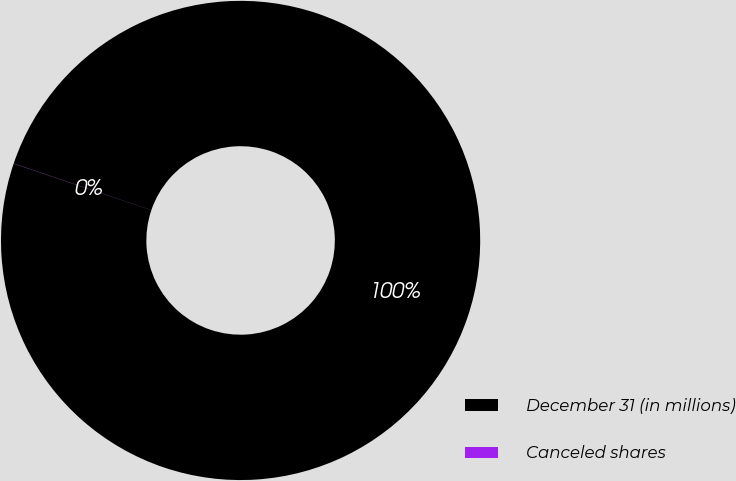<chart> <loc_0><loc_0><loc_500><loc_500><pie_chart><fcel>December 31 (in millions)<fcel>Canceled shares<nl><fcel>99.99%<fcel>0.01%<nl></chart> 